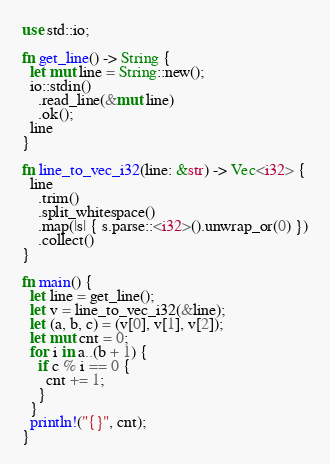Convert code to text. <code><loc_0><loc_0><loc_500><loc_500><_Rust_>use std::io;

fn get_line() -> String {
  let mut line = String::new();
  io::stdin()
    .read_line(&mut line)
    .ok();
  line
}

fn line_to_vec_i32(line: &str) -> Vec<i32> {
  line
    .trim()
    .split_whitespace()
    .map(|s| { s.parse::<i32>().unwrap_or(0) })
    .collect()
}

fn main() {
  let line = get_line();
  let v = line_to_vec_i32(&line);
  let (a, b, c) = (v[0], v[1], v[2]);
  let mut cnt = 0;
  for i in a..(b + 1) {
    if c % i == 0 {
      cnt += 1;
    }
  }
  println!("{}", cnt);
}

</code> 